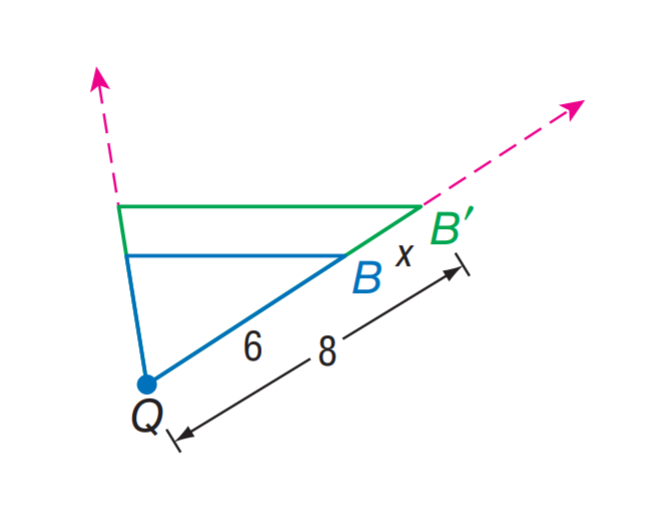Answer the mathemtical geometry problem and directly provide the correct option letter.
Question: Find x.
Choices: A: 2 B: 4 C: 6 D: 8 A 